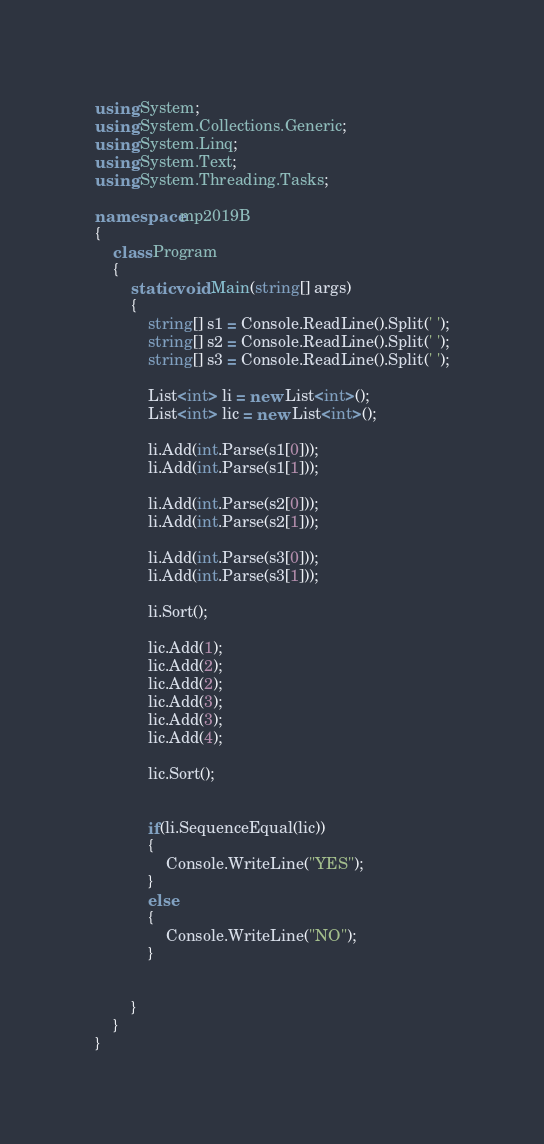<code> <loc_0><loc_0><loc_500><loc_500><_C#_>using System;
using System.Collections.Generic;
using System.Linq;
using System.Text;
using System.Threading.Tasks;

namespace mp2019B
{
    class Program
    {
        static void Main(string[] args)
        {
            string[] s1 = Console.ReadLine().Split(' ');
            string[] s2 = Console.ReadLine().Split(' ');
            string[] s3 = Console.ReadLine().Split(' ');

            List<int> li = new List<int>();
            List<int> lic = new List<int>();

            li.Add(int.Parse(s1[0]));
            li.Add(int.Parse(s1[1]));

            li.Add(int.Parse(s2[0]));
            li.Add(int.Parse(s2[1]));

            li.Add(int.Parse(s3[0]));
            li.Add(int.Parse(s3[1]));

            li.Sort();

            lic.Add(1);
            lic.Add(2);
            lic.Add(2);
            lic.Add(3);
            lic.Add(3);
            lic.Add(4);

            lic.Sort();


            if(li.SequenceEqual(lic))
            {
                Console.WriteLine("YES");
            }
            else
            {
                Console.WriteLine("NO");
            }


        }
    }
}
</code> 